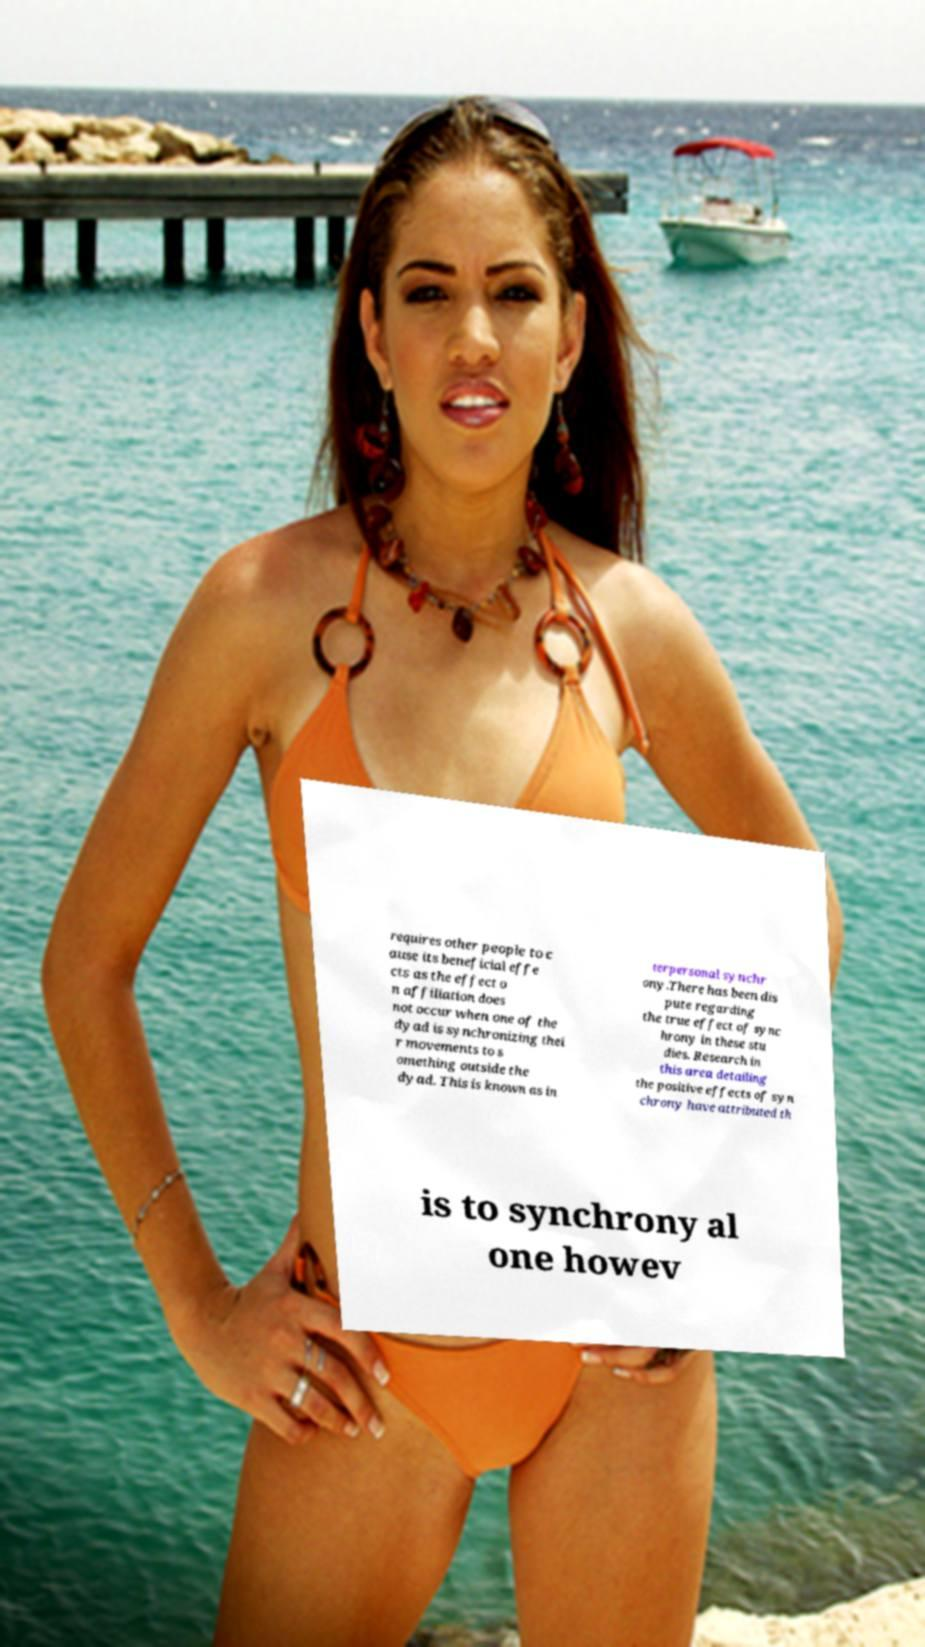Can you read and provide the text displayed in the image?This photo seems to have some interesting text. Can you extract and type it out for me? requires other people to c ause its beneficial effe cts as the effect o n affiliation does not occur when one of the dyad is synchronizing thei r movements to s omething outside the dyad. This is known as in terpersonal synchr ony.There has been dis pute regarding the true effect of sync hrony in these stu dies. Research in this area detailing the positive effects of syn chrony have attributed th is to synchrony al one howev 